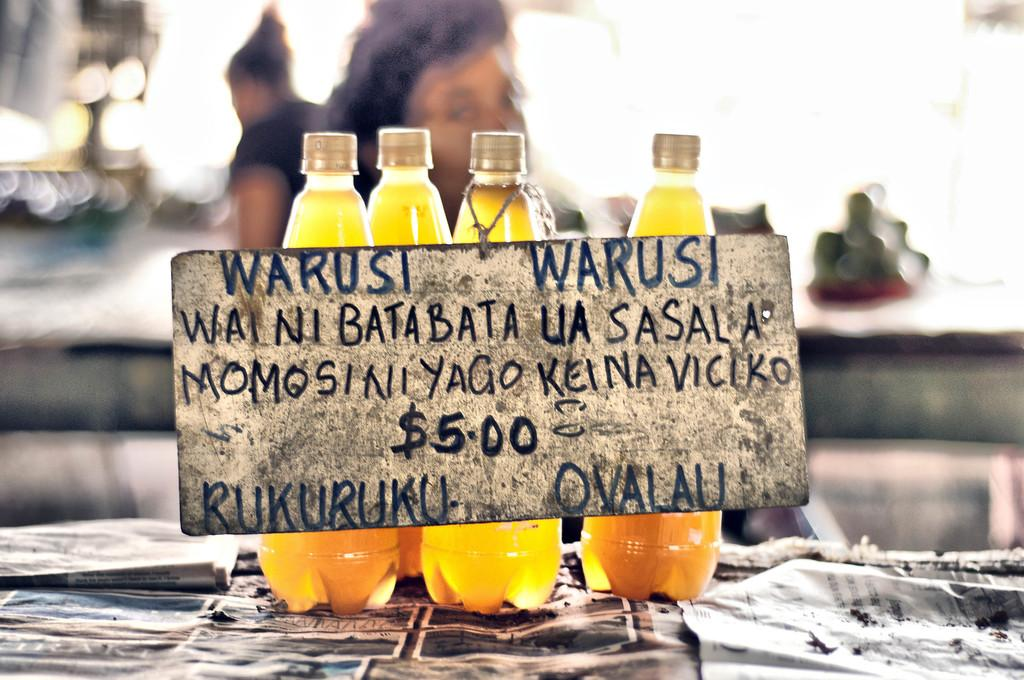How many bottles are on the table in the image? There are four bottles on the table in the image. What is placed on top of the bottles? There is a board on the bottles. What can be seen written on the board? Something is written on the board. Can you describe the people visible behind the bottles? There is a couple of women visible behind the bottles. How much dirt is visible on the board in the image? There is no dirt visible on the board in the image. What type of hen can be seen interacting with the couple of women in the image? There is no hen present in the image; it only features a couple of women and the board on the bottles. 